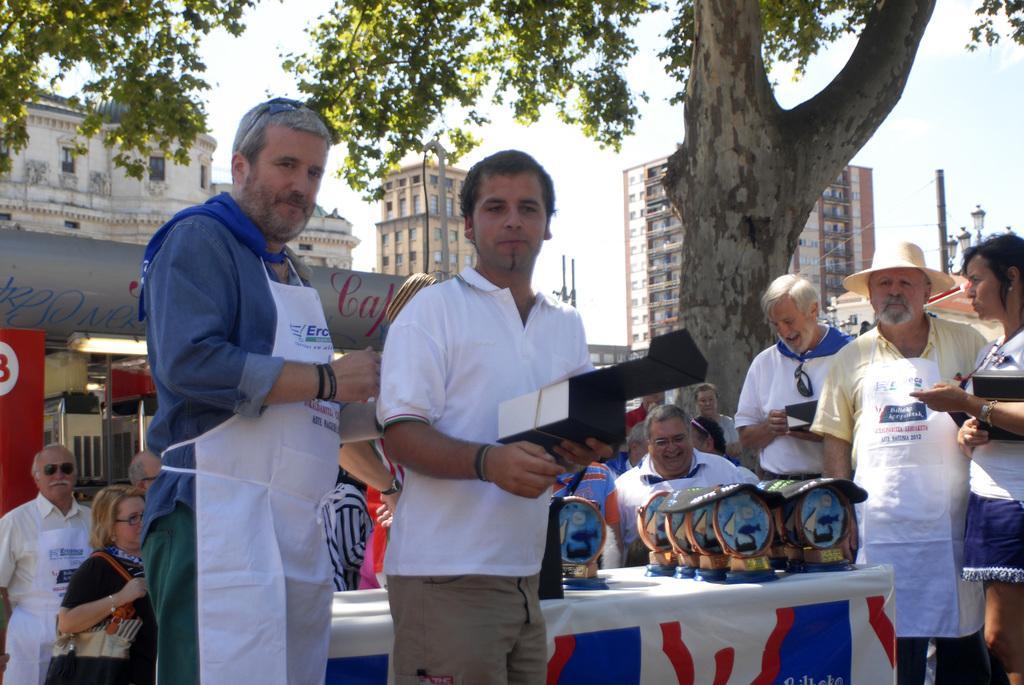Could you give a brief overview of what you see in this image? In this picture there is a man who is wearing white t-shirt and trouser. He is also holding a black box. Beside him we can see an old man who is wearing shirt and trouser. Both of them are standing near to the table. On the table we can see prizes. Here we can see group of person standing near to the tree. Here we can see many buildings. On the right we can see black pole and street lights. Here we can see sky and clouds. 